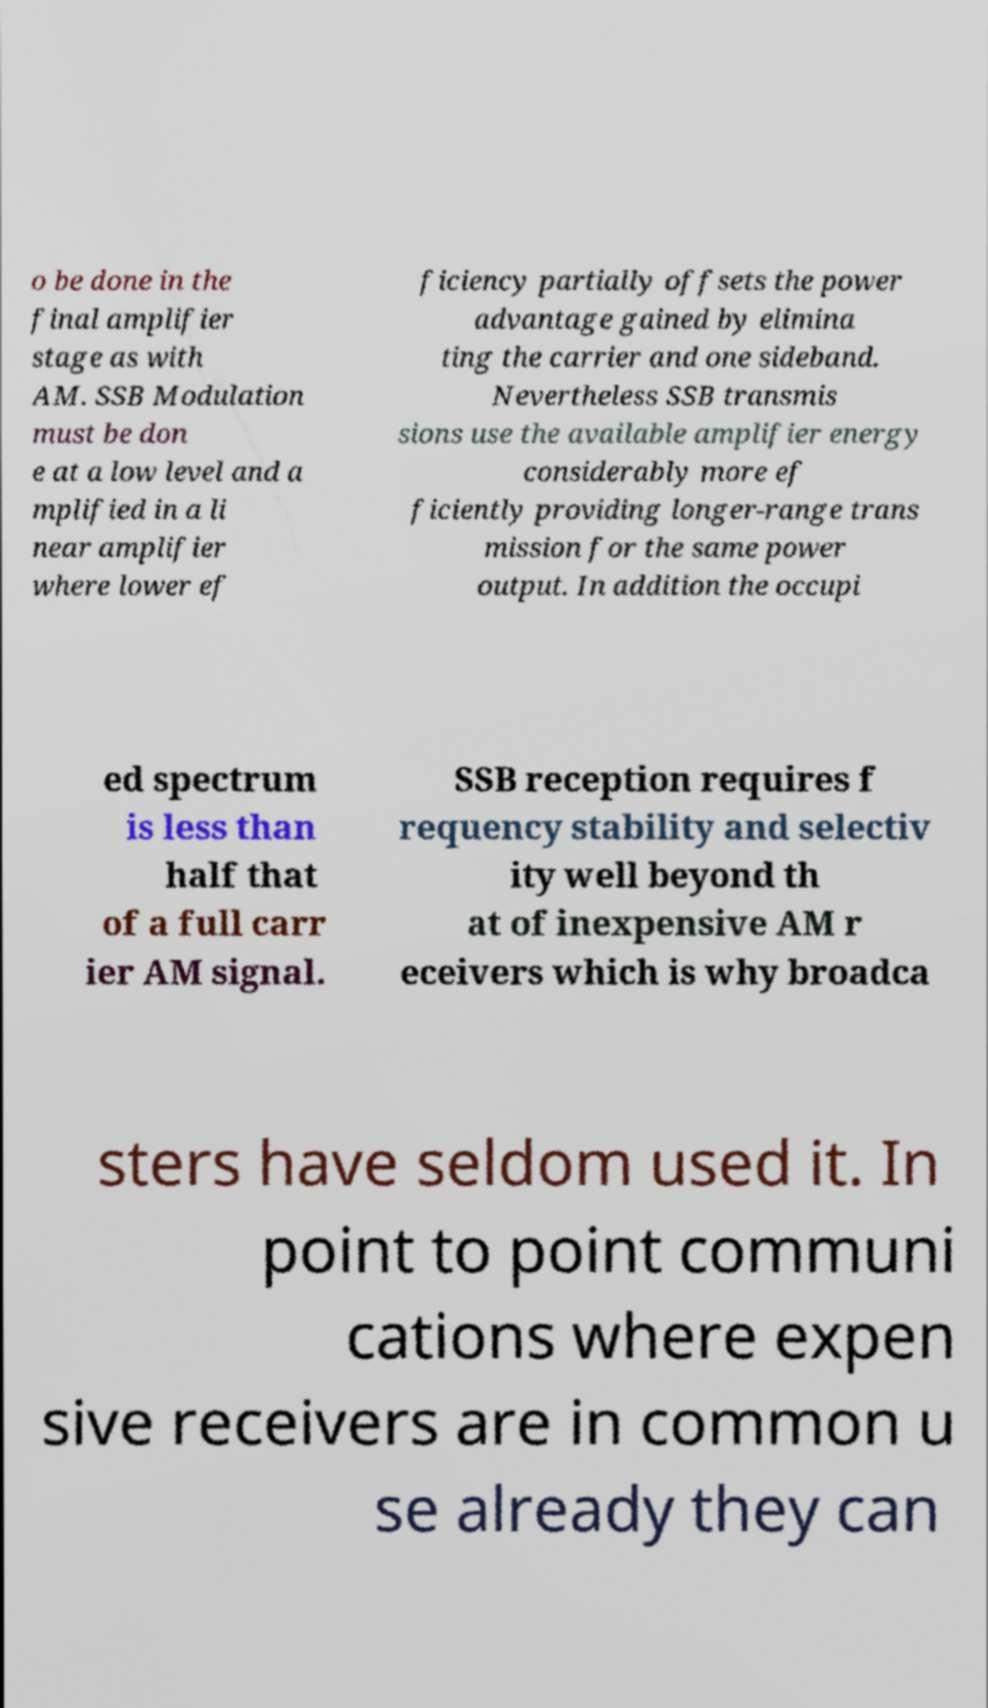Please read and relay the text visible in this image. What does it say? o be done in the final amplifier stage as with AM. SSB Modulation must be don e at a low level and a mplified in a li near amplifier where lower ef ficiency partially offsets the power advantage gained by elimina ting the carrier and one sideband. Nevertheless SSB transmis sions use the available amplifier energy considerably more ef ficiently providing longer-range trans mission for the same power output. In addition the occupi ed spectrum is less than half that of a full carr ier AM signal. SSB reception requires f requency stability and selectiv ity well beyond th at of inexpensive AM r eceivers which is why broadca sters have seldom used it. In point to point communi cations where expen sive receivers are in common u se already they can 